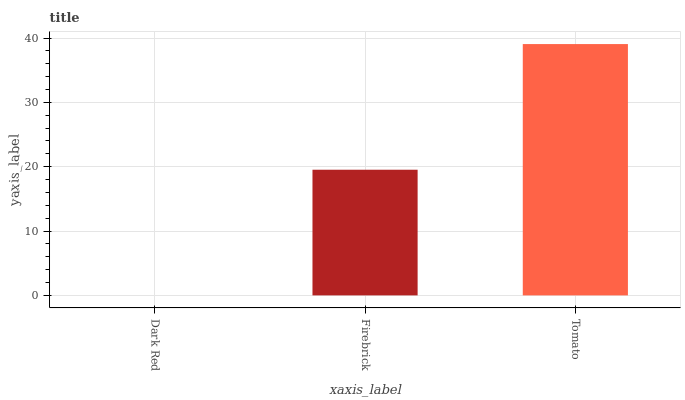Is Dark Red the minimum?
Answer yes or no. Yes. Is Tomato the maximum?
Answer yes or no. Yes. Is Firebrick the minimum?
Answer yes or no. No. Is Firebrick the maximum?
Answer yes or no. No. Is Firebrick greater than Dark Red?
Answer yes or no. Yes. Is Dark Red less than Firebrick?
Answer yes or no. Yes. Is Dark Red greater than Firebrick?
Answer yes or no. No. Is Firebrick less than Dark Red?
Answer yes or no. No. Is Firebrick the high median?
Answer yes or no. Yes. Is Firebrick the low median?
Answer yes or no. Yes. Is Tomato the high median?
Answer yes or no. No. Is Tomato the low median?
Answer yes or no. No. 